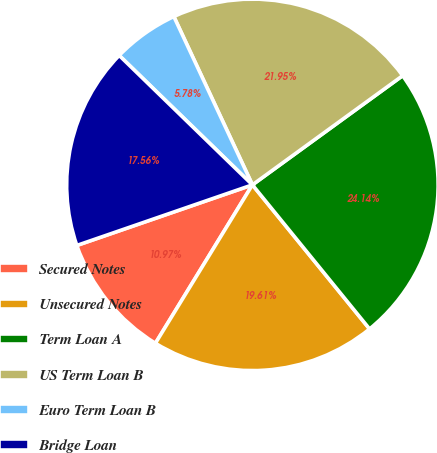Convert chart to OTSL. <chart><loc_0><loc_0><loc_500><loc_500><pie_chart><fcel>Secured Notes<fcel>Unsecured Notes<fcel>Term Loan A<fcel>US Term Loan B<fcel>Euro Term Loan B<fcel>Bridge Loan<nl><fcel>10.97%<fcel>19.61%<fcel>24.14%<fcel>21.95%<fcel>5.78%<fcel>17.56%<nl></chart> 